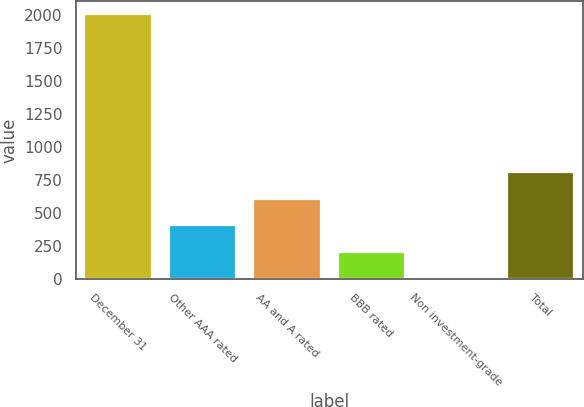Convert chart. <chart><loc_0><loc_0><loc_500><loc_500><bar_chart><fcel>December 31<fcel>Other AAA rated<fcel>AA and A rated<fcel>BBB rated<fcel>Non investment-grade<fcel>Total<nl><fcel>2004<fcel>405.6<fcel>605.4<fcel>205.8<fcel>6<fcel>805.2<nl></chart> 